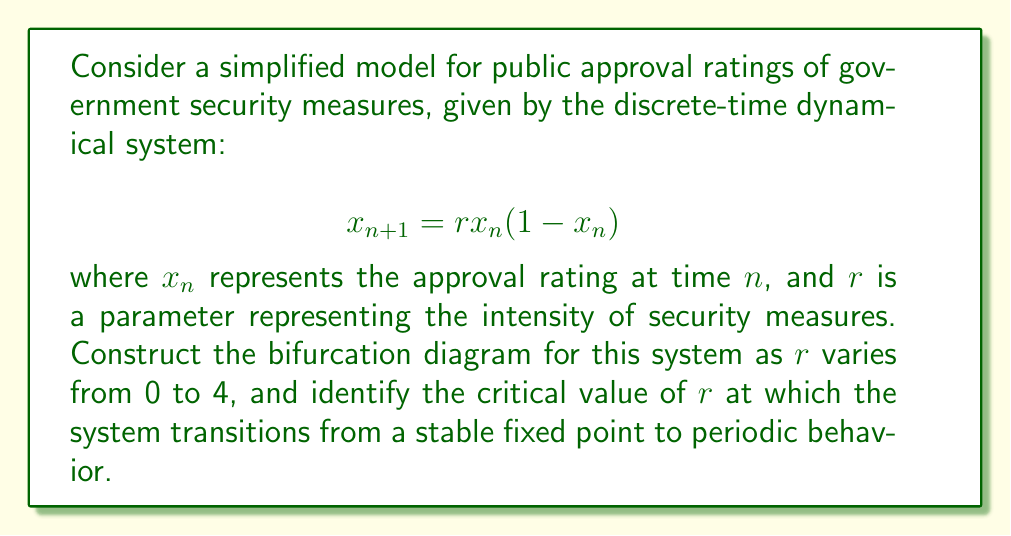Give your solution to this math problem. To construct the bifurcation diagram and find the critical value:

1) First, we need to find the fixed points of the system:
   Set $x_{n+1} = x_n = x^*$
   $$x^* = rx^*(1-x^*)$$
   Solving this, we get $x^* = 0$ or $x^* = 1 - \frac{1}{r}$

2) For stability analysis, we calculate the derivative:
   $$f'(x) = r(1-2x)$$

3) At $x^* = 1 - \frac{1}{r}$, the derivative is:
   $$f'(1-\frac{1}{r}) = r(1-2(1-\frac{1}{r})) = 2-r$$

4) The fixed point is stable when $|f'(x^*)| < 1$:
   $$|2-r| < 1$$
   $$1 < r < 3$$

5) The critical value where the system transitions from a stable fixed point to periodic behavior is when $r = 3$.

6) To construct the bifurcation diagram:
   - For $0 < r < 1$, the only stable fixed point is $x^* = 0$
   - For $1 < r < 3$, the stable fixed point is $x^* = 1 - \frac{1}{r}$
   - At $r = 3$, a period-doubling bifurcation occurs
   - For $3 < r < 3.57$ (approx.), the system exhibits periodic behavior
   - For $r > 3.57$ (approx.), the system becomes chaotic with some periodic windows

7) The bifurcation diagram would show:
   - A single line from $r = 1$ to $r = 3$
   - Two lines (period-2) emerging at $r = 3$
   - Further period-doubling as $r$ increases
   - Chaos interspersed with periodic windows for larger $r$ values

[asy]
size(200,150);
real f(real x, real r) {return r*x*(1-x);}
for(real r=2.5; r<=4; r+=0.005) {
  real x=0.5;
  for(int i=0; i<1000; ++i) {
    x=f(x,r);
    if(i>100) dot((r,x),rgb(0,0,0)+opacity(0.1));
  }
}
xaxis("r",2.5,4,arrow=Arrow);
yaxis("x",0,1,arrow=Arrow);
label("Bifurcation Diagram",point(S),S);
[/asy]
Answer: Critical value: $r = 3$ 